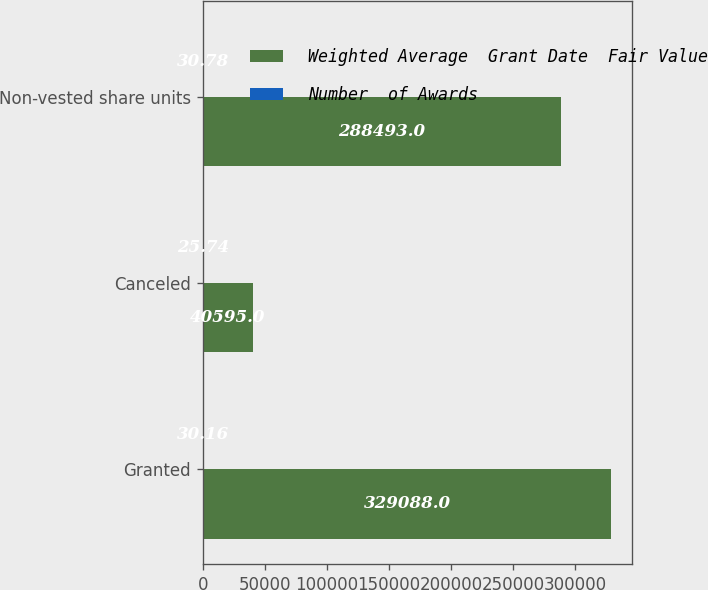Convert chart to OTSL. <chart><loc_0><loc_0><loc_500><loc_500><stacked_bar_chart><ecel><fcel>Granted<fcel>Canceled<fcel>Non-vested share units<nl><fcel>Weighted Average  Grant Date  Fair Value<fcel>329088<fcel>40595<fcel>288493<nl><fcel>Number  of Awards<fcel>30.16<fcel>25.74<fcel>30.78<nl></chart> 